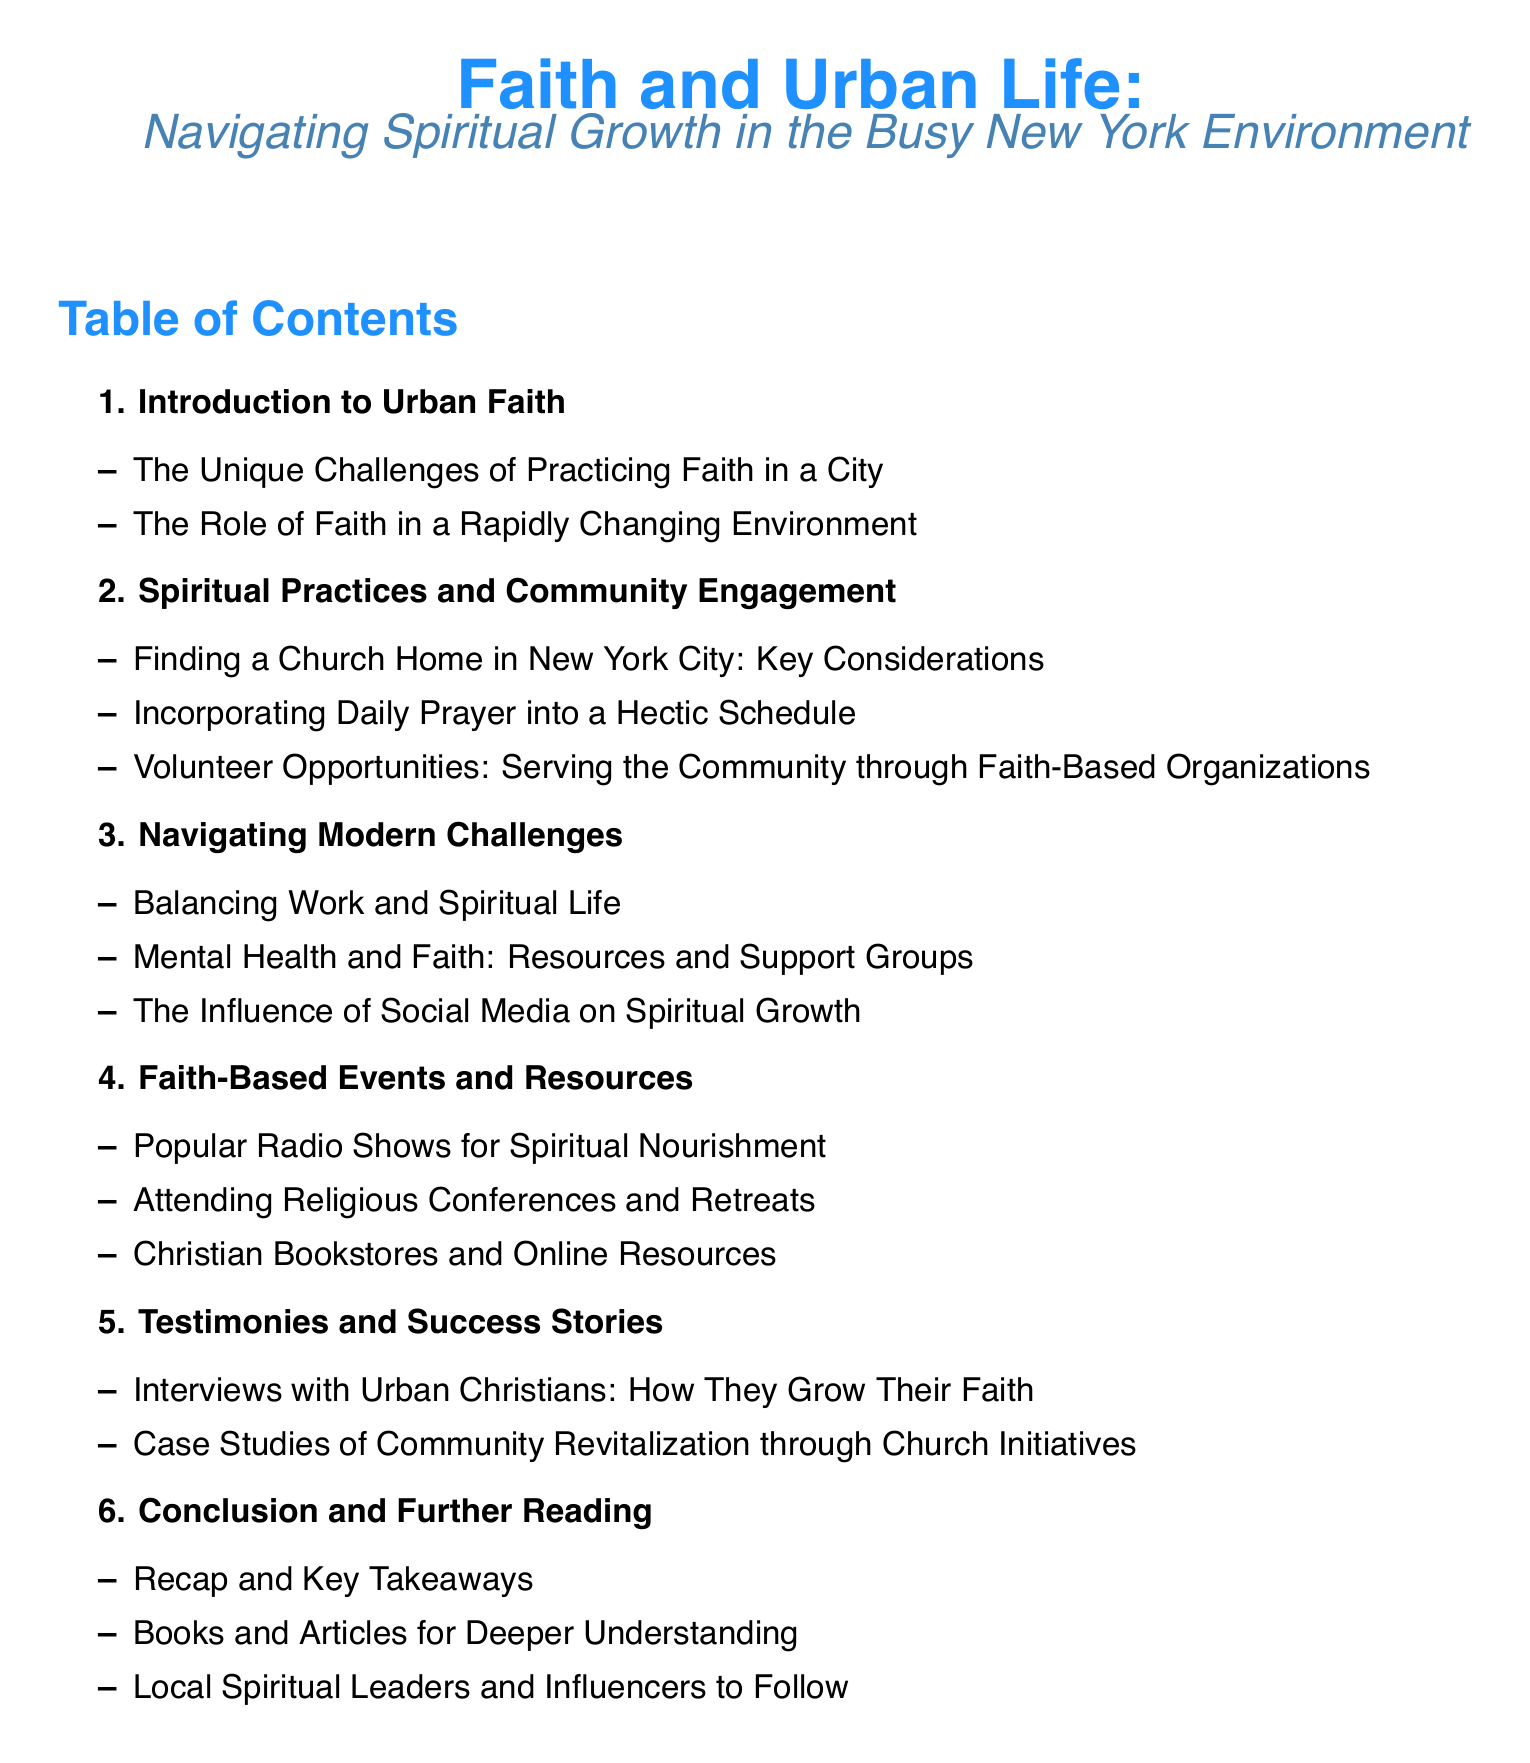what is the first section of the document? The first section listed in the Table of Contents is "Introduction to Urban Faith."
Answer: Introduction to Urban Faith how many subsections are under "Spiritual Practices and Community Engagement"? The section "Spiritual Practices and Community Engagement" includes three subsections.
Answer: 3 what is one key consideration for finding a church home in New York City? The document does not specify just one consideration, but it discusses the process of finding a church home, indicating that there are key considerations involved.
Answer: Key Considerations which topic covers balancing work and spiritual life? The topic that discusses balancing work and spiritual life is "Navigating Modern Challenges."
Answer: Navigating Modern Challenges how many testimonies and success stories are presented in the document? The section "Testimonies and Success Stories" contains two subsections.
Answer: 2 what type of resources are mentioned in relation to mental health and faith? The document refers to "Resources and Support Groups" for mental health and faith.
Answer: Resources and Support Groups name one popular activity for spiritual nourishment mentioned in the document. The document lists "Popular Radio Shows for Spiritual Nourishment" as one of the activities.
Answer: Popular Radio Shows what is the concluding section of the document? The section that concludes the document is "Conclusion and Further Reading."
Answer: Conclusion and Further Reading how many main sections are outlined in the Table of Contents? There are six main sections outlined in the Table of Contents.
Answer: 6 